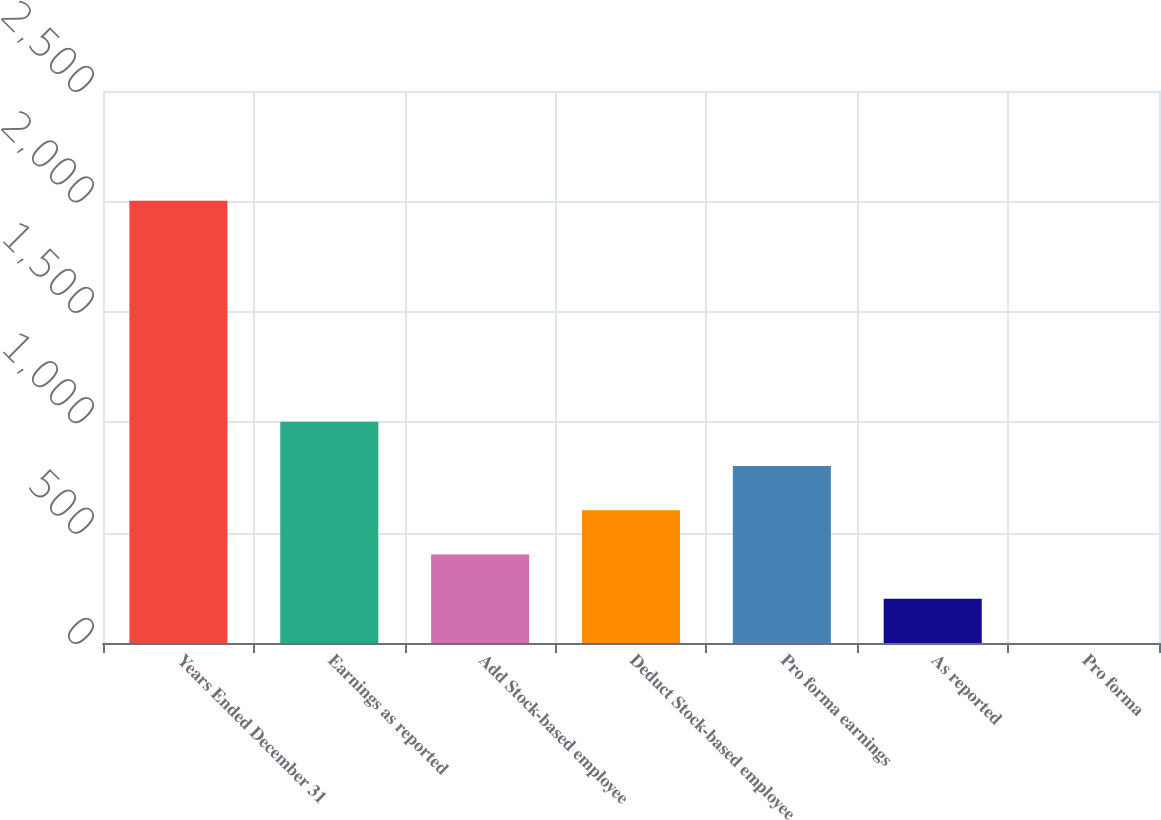<chart> <loc_0><loc_0><loc_500><loc_500><bar_chart><fcel>Years Ended December 31<fcel>Earnings as reported<fcel>Add Stock-based employee<fcel>Deduct Stock-based employee<fcel>Pro forma earnings<fcel>As reported<fcel>Pro forma<nl><fcel>2003<fcel>1001.68<fcel>400.87<fcel>601.14<fcel>801.41<fcel>200.6<fcel>0.33<nl></chart> 